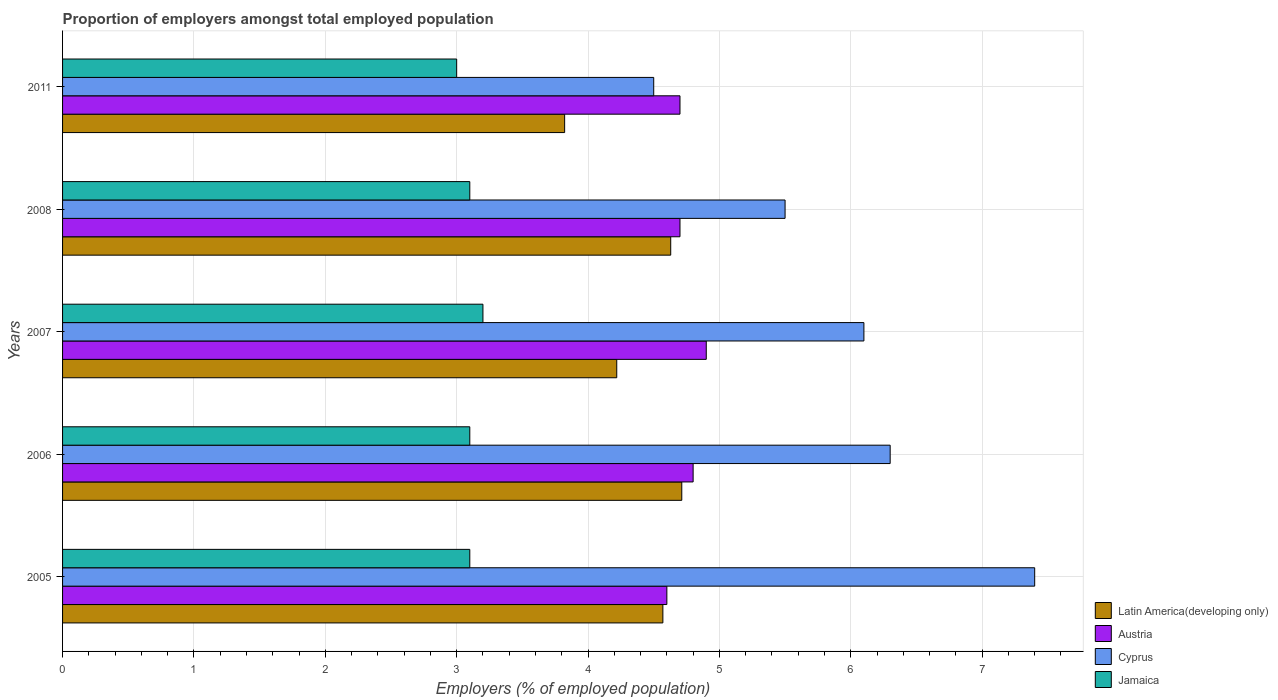How many different coloured bars are there?
Offer a terse response. 4. How many bars are there on the 1st tick from the top?
Your answer should be compact. 4. In how many cases, is the number of bars for a given year not equal to the number of legend labels?
Give a very brief answer. 0. What is the proportion of employers in Austria in 2008?
Offer a very short reply. 4.7. Across all years, what is the maximum proportion of employers in Latin America(developing only)?
Ensure brevity in your answer.  4.71. Across all years, what is the minimum proportion of employers in Cyprus?
Your answer should be very brief. 4.5. In which year was the proportion of employers in Latin America(developing only) maximum?
Your response must be concise. 2006. In which year was the proportion of employers in Jamaica minimum?
Your answer should be very brief. 2011. What is the total proportion of employers in Cyprus in the graph?
Make the answer very short. 29.8. What is the difference between the proportion of employers in Cyprus in 2005 and that in 2007?
Give a very brief answer. 1.3. What is the difference between the proportion of employers in Cyprus in 2005 and the proportion of employers in Jamaica in 2007?
Provide a succinct answer. 4.2. What is the average proportion of employers in Cyprus per year?
Offer a terse response. 5.96. In the year 2011, what is the difference between the proportion of employers in Latin America(developing only) and proportion of employers in Cyprus?
Your answer should be very brief. -0.68. What is the difference between the highest and the second highest proportion of employers in Latin America(developing only)?
Keep it short and to the point. 0.08. What is the difference between the highest and the lowest proportion of employers in Cyprus?
Provide a short and direct response. 2.9. In how many years, is the proportion of employers in Jamaica greater than the average proportion of employers in Jamaica taken over all years?
Provide a succinct answer. 1. Is the sum of the proportion of employers in Austria in 2005 and 2008 greater than the maximum proportion of employers in Latin America(developing only) across all years?
Provide a succinct answer. Yes. What does the 3rd bar from the top in 2008 represents?
Offer a very short reply. Austria. Is it the case that in every year, the sum of the proportion of employers in Jamaica and proportion of employers in Latin America(developing only) is greater than the proportion of employers in Cyprus?
Provide a succinct answer. Yes. Are all the bars in the graph horizontal?
Make the answer very short. Yes. Are the values on the major ticks of X-axis written in scientific E-notation?
Offer a terse response. No. Does the graph contain any zero values?
Offer a terse response. No. What is the title of the graph?
Your answer should be compact. Proportion of employers amongst total employed population. Does "West Bank and Gaza" appear as one of the legend labels in the graph?
Ensure brevity in your answer.  No. What is the label or title of the X-axis?
Your answer should be compact. Employers (% of employed population). What is the Employers (% of employed population) in Latin America(developing only) in 2005?
Your answer should be very brief. 4.57. What is the Employers (% of employed population) in Austria in 2005?
Give a very brief answer. 4.6. What is the Employers (% of employed population) of Cyprus in 2005?
Offer a very short reply. 7.4. What is the Employers (% of employed population) in Jamaica in 2005?
Make the answer very short. 3.1. What is the Employers (% of employed population) of Latin America(developing only) in 2006?
Offer a very short reply. 4.71. What is the Employers (% of employed population) of Austria in 2006?
Give a very brief answer. 4.8. What is the Employers (% of employed population) in Cyprus in 2006?
Make the answer very short. 6.3. What is the Employers (% of employed population) in Jamaica in 2006?
Offer a very short reply. 3.1. What is the Employers (% of employed population) of Latin America(developing only) in 2007?
Make the answer very short. 4.22. What is the Employers (% of employed population) in Austria in 2007?
Make the answer very short. 4.9. What is the Employers (% of employed population) in Cyprus in 2007?
Offer a very short reply. 6.1. What is the Employers (% of employed population) of Jamaica in 2007?
Give a very brief answer. 3.2. What is the Employers (% of employed population) of Latin America(developing only) in 2008?
Provide a succinct answer. 4.63. What is the Employers (% of employed population) in Austria in 2008?
Offer a very short reply. 4.7. What is the Employers (% of employed population) in Jamaica in 2008?
Keep it short and to the point. 3.1. What is the Employers (% of employed population) in Latin America(developing only) in 2011?
Keep it short and to the point. 3.82. What is the Employers (% of employed population) of Austria in 2011?
Provide a short and direct response. 4.7. What is the Employers (% of employed population) of Cyprus in 2011?
Keep it short and to the point. 4.5. Across all years, what is the maximum Employers (% of employed population) of Latin America(developing only)?
Make the answer very short. 4.71. Across all years, what is the maximum Employers (% of employed population) in Austria?
Offer a very short reply. 4.9. Across all years, what is the maximum Employers (% of employed population) of Cyprus?
Offer a terse response. 7.4. Across all years, what is the maximum Employers (% of employed population) of Jamaica?
Keep it short and to the point. 3.2. Across all years, what is the minimum Employers (% of employed population) in Latin America(developing only)?
Your answer should be compact. 3.82. Across all years, what is the minimum Employers (% of employed population) of Austria?
Offer a terse response. 4.6. What is the total Employers (% of employed population) in Latin America(developing only) in the graph?
Your answer should be very brief. 21.95. What is the total Employers (% of employed population) of Austria in the graph?
Your response must be concise. 23.7. What is the total Employers (% of employed population) of Cyprus in the graph?
Ensure brevity in your answer.  29.8. What is the total Employers (% of employed population) of Jamaica in the graph?
Offer a very short reply. 15.5. What is the difference between the Employers (% of employed population) of Latin America(developing only) in 2005 and that in 2006?
Your answer should be very brief. -0.14. What is the difference between the Employers (% of employed population) in Austria in 2005 and that in 2006?
Keep it short and to the point. -0.2. What is the difference between the Employers (% of employed population) of Latin America(developing only) in 2005 and that in 2007?
Your response must be concise. 0.35. What is the difference between the Employers (% of employed population) in Latin America(developing only) in 2005 and that in 2008?
Make the answer very short. -0.06. What is the difference between the Employers (% of employed population) in Cyprus in 2005 and that in 2008?
Keep it short and to the point. 1.9. What is the difference between the Employers (% of employed population) in Jamaica in 2005 and that in 2008?
Make the answer very short. 0. What is the difference between the Employers (% of employed population) of Latin America(developing only) in 2005 and that in 2011?
Give a very brief answer. 0.75. What is the difference between the Employers (% of employed population) of Cyprus in 2005 and that in 2011?
Give a very brief answer. 2.9. What is the difference between the Employers (% of employed population) in Jamaica in 2005 and that in 2011?
Ensure brevity in your answer.  0.1. What is the difference between the Employers (% of employed population) of Latin America(developing only) in 2006 and that in 2007?
Offer a terse response. 0.49. What is the difference between the Employers (% of employed population) of Austria in 2006 and that in 2007?
Give a very brief answer. -0.1. What is the difference between the Employers (% of employed population) of Cyprus in 2006 and that in 2007?
Provide a succinct answer. 0.2. What is the difference between the Employers (% of employed population) in Jamaica in 2006 and that in 2007?
Offer a terse response. -0.1. What is the difference between the Employers (% of employed population) in Latin America(developing only) in 2006 and that in 2008?
Keep it short and to the point. 0.08. What is the difference between the Employers (% of employed population) of Cyprus in 2006 and that in 2008?
Give a very brief answer. 0.8. What is the difference between the Employers (% of employed population) in Latin America(developing only) in 2006 and that in 2011?
Make the answer very short. 0.89. What is the difference between the Employers (% of employed population) of Austria in 2006 and that in 2011?
Make the answer very short. 0.1. What is the difference between the Employers (% of employed population) in Cyprus in 2006 and that in 2011?
Provide a succinct answer. 1.8. What is the difference between the Employers (% of employed population) in Latin America(developing only) in 2007 and that in 2008?
Your answer should be very brief. -0.41. What is the difference between the Employers (% of employed population) of Cyprus in 2007 and that in 2008?
Keep it short and to the point. 0.6. What is the difference between the Employers (% of employed population) of Latin America(developing only) in 2007 and that in 2011?
Your answer should be compact. 0.4. What is the difference between the Employers (% of employed population) in Austria in 2007 and that in 2011?
Give a very brief answer. 0.2. What is the difference between the Employers (% of employed population) of Latin America(developing only) in 2008 and that in 2011?
Ensure brevity in your answer.  0.81. What is the difference between the Employers (% of employed population) of Jamaica in 2008 and that in 2011?
Provide a short and direct response. 0.1. What is the difference between the Employers (% of employed population) in Latin America(developing only) in 2005 and the Employers (% of employed population) in Austria in 2006?
Your answer should be compact. -0.23. What is the difference between the Employers (% of employed population) in Latin America(developing only) in 2005 and the Employers (% of employed population) in Cyprus in 2006?
Keep it short and to the point. -1.73. What is the difference between the Employers (% of employed population) of Latin America(developing only) in 2005 and the Employers (% of employed population) of Jamaica in 2006?
Your answer should be compact. 1.47. What is the difference between the Employers (% of employed population) of Cyprus in 2005 and the Employers (% of employed population) of Jamaica in 2006?
Provide a short and direct response. 4.3. What is the difference between the Employers (% of employed population) in Latin America(developing only) in 2005 and the Employers (% of employed population) in Austria in 2007?
Give a very brief answer. -0.33. What is the difference between the Employers (% of employed population) of Latin America(developing only) in 2005 and the Employers (% of employed population) of Cyprus in 2007?
Provide a short and direct response. -1.53. What is the difference between the Employers (% of employed population) in Latin America(developing only) in 2005 and the Employers (% of employed population) in Jamaica in 2007?
Your answer should be very brief. 1.37. What is the difference between the Employers (% of employed population) of Austria in 2005 and the Employers (% of employed population) of Cyprus in 2007?
Give a very brief answer. -1.5. What is the difference between the Employers (% of employed population) of Cyprus in 2005 and the Employers (% of employed population) of Jamaica in 2007?
Provide a succinct answer. 4.2. What is the difference between the Employers (% of employed population) of Latin America(developing only) in 2005 and the Employers (% of employed population) of Austria in 2008?
Provide a short and direct response. -0.13. What is the difference between the Employers (% of employed population) in Latin America(developing only) in 2005 and the Employers (% of employed population) in Cyprus in 2008?
Your answer should be very brief. -0.93. What is the difference between the Employers (% of employed population) in Latin America(developing only) in 2005 and the Employers (% of employed population) in Jamaica in 2008?
Offer a very short reply. 1.47. What is the difference between the Employers (% of employed population) of Austria in 2005 and the Employers (% of employed population) of Jamaica in 2008?
Provide a short and direct response. 1.5. What is the difference between the Employers (% of employed population) of Cyprus in 2005 and the Employers (% of employed population) of Jamaica in 2008?
Offer a very short reply. 4.3. What is the difference between the Employers (% of employed population) in Latin America(developing only) in 2005 and the Employers (% of employed population) in Austria in 2011?
Give a very brief answer. -0.13. What is the difference between the Employers (% of employed population) in Latin America(developing only) in 2005 and the Employers (% of employed population) in Cyprus in 2011?
Give a very brief answer. 0.07. What is the difference between the Employers (% of employed population) in Latin America(developing only) in 2005 and the Employers (% of employed population) in Jamaica in 2011?
Offer a terse response. 1.57. What is the difference between the Employers (% of employed population) of Austria in 2005 and the Employers (% of employed population) of Jamaica in 2011?
Your answer should be compact. 1.6. What is the difference between the Employers (% of employed population) in Latin America(developing only) in 2006 and the Employers (% of employed population) in Austria in 2007?
Your response must be concise. -0.19. What is the difference between the Employers (% of employed population) in Latin America(developing only) in 2006 and the Employers (% of employed population) in Cyprus in 2007?
Your answer should be compact. -1.39. What is the difference between the Employers (% of employed population) in Latin America(developing only) in 2006 and the Employers (% of employed population) in Jamaica in 2007?
Your answer should be very brief. 1.51. What is the difference between the Employers (% of employed population) in Austria in 2006 and the Employers (% of employed population) in Cyprus in 2007?
Your response must be concise. -1.3. What is the difference between the Employers (% of employed population) in Austria in 2006 and the Employers (% of employed population) in Jamaica in 2007?
Give a very brief answer. 1.6. What is the difference between the Employers (% of employed population) of Cyprus in 2006 and the Employers (% of employed population) of Jamaica in 2007?
Offer a very short reply. 3.1. What is the difference between the Employers (% of employed population) in Latin America(developing only) in 2006 and the Employers (% of employed population) in Austria in 2008?
Ensure brevity in your answer.  0.01. What is the difference between the Employers (% of employed population) in Latin America(developing only) in 2006 and the Employers (% of employed population) in Cyprus in 2008?
Your answer should be very brief. -0.79. What is the difference between the Employers (% of employed population) in Latin America(developing only) in 2006 and the Employers (% of employed population) in Jamaica in 2008?
Provide a succinct answer. 1.61. What is the difference between the Employers (% of employed population) in Cyprus in 2006 and the Employers (% of employed population) in Jamaica in 2008?
Make the answer very short. 3.2. What is the difference between the Employers (% of employed population) in Latin America(developing only) in 2006 and the Employers (% of employed population) in Austria in 2011?
Provide a short and direct response. 0.01. What is the difference between the Employers (% of employed population) of Latin America(developing only) in 2006 and the Employers (% of employed population) of Cyprus in 2011?
Make the answer very short. 0.21. What is the difference between the Employers (% of employed population) of Latin America(developing only) in 2006 and the Employers (% of employed population) of Jamaica in 2011?
Your response must be concise. 1.71. What is the difference between the Employers (% of employed population) in Cyprus in 2006 and the Employers (% of employed population) in Jamaica in 2011?
Offer a very short reply. 3.3. What is the difference between the Employers (% of employed population) of Latin America(developing only) in 2007 and the Employers (% of employed population) of Austria in 2008?
Keep it short and to the point. -0.48. What is the difference between the Employers (% of employed population) of Latin America(developing only) in 2007 and the Employers (% of employed population) of Cyprus in 2008?
Your answer should be very brief. -1.28. What is the difference between the Employers (% of employed population) of Latin America(developing only) in 2007 and the Employers (% of employed population) of Jamaica in 2008?
Offer a very short reply. 1.12. What is the difference between the Employers (% of employed population) in Austria in 2007 and the Employers (% of employed population) in Cyprus in 2008?
Offer a very short reply. -0.6. What is the difference between the Employers (% of employed population) of Latin America(developing only) in 2007 and the Employers (% of employed population) of Austria in 2011?
Provide a short and direct response. -0.48. What is the difference between the Employers (% of employed population) in Latin America(developing only) in 2007 and the Employers (% of employed population) in Cyprus in 2011?
Offer a terse response. -0.28. What is the difference between the Employers (% of employed population) in Latin America(developing only) in 2007 and the Employers (% of employed population) in Jamaica in 2011?
Your answer should be very brief. 1.22. What is the difference between the Employers (% of employed population) of Austria in 2007 and the Employers (% of employed population) of Cyprus in 2011?
Offer a very short reply. 0.4. What is the difference between the Employers (% of employed population) of Austria in 2007 and the Employers (% of employed population) of Jamaica in 2011?
Keep it short and to the point. 1.9. What is the difference between the Employers (% of employed population) in Latin America(developing only) in 2008 and the Employers (% of employed population) in Austria in 2011?
Offer a very short reply. -0.07. What is the difference between the Employers (% of employed population) of Latin America(developing only) in 2008 and the Employers (% of employed population) of Cyprus in 2011?
Offer a very short reply. 0.13. What is the difference between the Employers (% of employed population) in Latin America(developing only) in 2008 and the Employers (% of employed population) in Jamaica in 2011?
Keep it short and to the point. 1.63. What is the difference between the Employers (% of employed population) of Austria in 2008 and the Employers (% of employed population) of Cyprus in 2011?
Offer a very short reply. 0.2. What is the difference between the Employers (% of employed population) of Austria in 2008 and the Employers (% of employed population) of Jamaica in 2011?
Offer a terse response. 1.7. What is the difference between the Employers (% of employed population) in Cyprus in 2008 and the Employers (% of employed population) in Jamaica in 2011?
Offer a very short reply. 2.5. What is the average Employers (% of employed population) of Latin America(developing only) per year?
Provide a short and direct response. 4.39. What is the average Employers (% of employed population) of Austria per year?
Provide a short and direct response. 4.74. What is the average Employers (% of employed population) in Cyprus per year?
Your answer should be compact. 5.96. What is the average Employers (% of employed population) of Jamaica per year?
Make the answer very short. 3.1. In the year 2005, what is the difference between the Employers (% of employed population) in Latin America(developing only) and Employers (% of employed population) in Austria?
Offer a terse response. -0.03. In the year 2005, what is the difference between the Employers (% of employed population) of Latin America(developing only) and Employers (% of employed population) of Cyprus?
Make the answer very short. -2.83. In the year 2005, what is the difference between the Employers (% of employed population) in Latin America(developing only) and Employers (% of employed population) in Jamaica?
Provide a short and direct response. 1.47. In the year 2005, what is the difference between the Employers (% of employed population) of Austria and Employers (% of employed population) of Cyprus?
Your answer should be very brief. -2.8. In the year 2005, what is the difference between the Employers (% of employed population) in Austria and Employers (% of employed population) in Jamaica?
Offer a terse response. 1.5. In the year 2006, what is the difference between the Employers (% of employed population) of Latin America(developing only) and Employers (% of employed population) of Austria?
Your response must be concise. -0.09. In the year 2006, what is the difference between the Employers (% of employed population) of Latin America(developing only) and Employers (% of employed population) of Cyprus?
Keep it short and to the point. -1.59. In the year 2006, what is the difference between the Employers (% of employed population) of Latin America(developing only) and Employers (% of employed population) of Jamaica?
Your answer should be compact. 1.61. In the year 2006, what is the difference between the Employers (% of employed population) of Austria and Employers (% of employed population) of Cyprus?
Your answer should be compact. -1.5. In the year 2006, what is the difference between the Employers (% of employed population) in Austria and Employers (% of employed population) in Jamaica?
Keep it short and to the point. 1.7. In the year 2006, what is the difference between the Employers (% of employed population) of Cyprus and Employers (% of employed population) of Jamaica?
Offer a very short reply. 3.2. In the year 2007, what is the difference between the Employers (% of employed population) of Latin America(developing only) and Employers (% of employed population) of Austria?
Provide a succinct answer. -0.68. In the year 2007, what is the difference between the Employers (% of employed population) in Latin America(developing only) and Employers (% of employed population) in Cyprus?
Offer a terse response. -1.88. In the year 2007, what is the difference between the Employers (% of employed population) of Latin America(developing only) and Employers (% of employed population) of Jamaica?
Your answer should be very brief. 1.02. In the year 2007, what is the difference between the Employers (% of employed population) in Austria and Employers (% of employed population) in Cyprus?
Offer a very short reply. -1.2. In the year 2007, what is the difference between the Employers (% of employed population) of Austria and Employers (% of employed population) of Jamaica?
Give a very brief answer. 1.7. In the year 2007, what is the difference between the Employers (% of employed population) of Cyprus and Employers (% of employed population) of Jamaica?
Offer a terse response. 2.9. In the year 2008, what is the difference between the Employers (% of employed population) in Latin America(developing only) and Employers (% of employed population) in Austria?
Keep it short and to the point. -0.07. In the year 2008, what is the difference between the Employers (% of employed population) in Latin America(developing only) and Employers (% of employed population) in Cyprus?
Your answer should be very brief. -0.87. In the year 2008, what is the difference between the Employers (% of employed population) in Latin America(developing only) and Employers (% of employed population) in Jamaica?
Offer a terse response. 1.53. In the year 2008, what is the difference between the Employers (% of employed population) in Austria and Employers (% of employed population) in Jamaica?
Your response must be concise. 1.6. In the year 2008, what is the difference between the Employers (% of employed population) in Cyprus and Employers (% of employed population) in Jamaica?
Give a very brief answer. 2.4. In the year 2011, what is the difference between the Employers (% of employed population) in Latin America(developing only) and Employers (% of employed population) in Austria?
Your answer should be very brief. -0.88. In the year 2011, what is the difference between the Employers (% of employed population) of Latin America(developing only) and Employers (% of employed population) of Cyprus?
Provide a succinct answer. -0.68. In the year 2011, what is the difference between the Employers (% of employed population) in Latin America(developing only) and Employers (% of employed population) in Jamaica?
Your answer should be very brief. 0.82. In the year 2011, what is the difference between the Employers (% of employed population) in Austria and Employers (% of employed population) in Jamaica?
Your answer should be very brief. 1.7. In the year 2011, what is the difference between the Employers (% of employed population) of Cyprus and Employers (% of employed population) of Jamaica?
Ensure brevity in your answer.  1.5. What is the ratio of the Employers (% of employed population) of Latin America(developing only) in 2005 to that in 2006?
Your response must be concise. 0.97. What is the ratio of the Employers (% of employed population) of Austria in 2005 to that in 2006?
Ensure brevity in your answer.  0.96. What is the ratio of the Employers (% of employed population) of Cyprus in 2005 to that in 2006?
Ensure brevity in your answer.  1.17. What is the ratio of the Employers (% of employed population) of Latin America(developing only) in 2005 to that in 2007?
Provide a succinct answer. 1.08. What is the ratio of the Employers (% of employed population) in Austria in 2005 to that in 2007?
Ensure brevity in your answer.  0.94. What is the ratio of the Employers (% of employed population) of Cyprus in 2005 to that in 2007?
Your answer should be compact. 1.21. What is the ratio of the Employers (% of employed population) in Jamaica in 2005 to that in 2007?
Provide a succinct answer. 0.97. What is the ratio of the Employers (% of employed population) in Latin America(developing only) in 2005 to that in 2008?
Your answer should be very brief. 0.99. What is the ratio of the Employers (% of employed population) in Austria in 2005 to that in 2008?
Ensure brevity in your answer.  0.98. What is the ratio of the Employers (% of employed population) in Cyprus in 2005 to that in 2008?
Offer a very short reply. 1.35. What is the ratio of the Employers (% of employed population) in Latin America(developing only) in 2005 to that in 2011?
Offer a terse response. 1.2. What is the ratio of the Employers (% of employed population) in Austria in 2005 to that in 2011?
Keep it short and to the point. 0.98. What is the ratio of the Employers (% of employed population) in Cyprus in 2005 to that in 2011?
Your response must be concise. 1.64. What is the ratio of the Employers (% of employed population) in Jamaica in 2005 to that in 2011?
Your response must be concise. 1.03. What is the ratio of the Employers (% of employed population) of Latin America(developing only) in 2006 to that in 2007?
Make the answer very short. 1.12. What is the ratio of the Employers (% of employed population) of Austria in 2006 to that in 2007?
Offer a terse response. 0.98. What is the ratio of the Employers (% of employed population) in Cyprus in 2006 to that in 2007?
Ensure brevity in your answer.  1.03. What is the ratio of the Employers (% of employed population) of Jamaica in 2006 to that in 2007?
Your answer should be compact. 0.97. What is the ratio of the Employers (% of employed population) of Latin America(developing only) in 2006 to that in 2008?
Give a very brief answer. 1.02. What is the ratio of the Employers (% of employed population) in Austria in 2006 to that in 2008?
Make the answer very short. 1.02. What is the ratio of the Employers (% of employed population) in Cyprus in 2006 to that in 2008?
Your answer should be very brief. 1.15. What is the ratio of the Employers (% of employed population) in Jamaica in 2006 to that in 2008?
Ensure brevity in your answer.  1. What is the ratio of the Employers (% of employed population) of Latin America(developing only) in 2006 to that in 2011?
Ensure brevity in your answer.  1.23. What is the ratio of the Employers (% of employed population) in Austria in 2006 to that in 2011?
Provide a succinct answer. 1.02. What is the ratio of the Employers (% of employed population) of Jamaica in 2006 to that in 2011?
Make the answer very short. 1.03. What is the ratio of the Employers (% of employed population) in Latin America(developing only) in 2007 to that in 2008?
Offer a very short reply. 0.91. What is the ratio of the Employers (% of employed population) in Austria in 2007 to that in 2008?
Your answer should be very brief. 1.04. What is the ratio of the Employers (% of employed population) of Cyprus in 2007 to that in 2008?
Keep it short and to the point. 1.11. What is the ratio of the Employers (% of employed population) of Jamaica in 2007 to that in 2008?
Your answer should be compact. 1.03. What is the ratio of the Employers (% of employed population) in Latin America(developing only) in 2007 to that in 2011?
Give a very brief answer. 1.1. What is the ratio of the Employers (% of employed population) of Austria in 2007 to that in 2011?
Keep it short and to the point. 1.04. What is the ratio of the Employers (% of employed population) of Cyprus in 2007 to that in 2011?
Your answer should be compact. 1.36. What is the ratio of the Employers (% of employed population) of Jamaica in 2007 to that in 2011?
Keep it short and to the point. 1.07. What is the ratio of the Employers (% of employed population) in Latin America(developing only) in 2008 to that in 2011?
Provide a short and direct response. 1.21. What is the ratio of the Employers (% of employed population) in Austria in 2008 to that in 2011?
Your answer should be compact. 1. What is the ratio of the Employers (% of employed population) in Cyprus in 2008 to that in 2011?
Keep it short and to the point. 1.22. What is the ratio of the Employers (% of employed population) in Jamaica in 2008 to that in 2011?
Offer a very short reply. 1.03. What is the difference between the highest and the second highest Employers (% of employed population) in Latin America(developing only)?
Your answer should be compact. 0.08. What is the difference between the highest and the second highest Employers (% of employed population) in Jamaica?
Offer a terse response. 0.1. What is the difference between the highest and the lowest Employers (% of employed population) in Latin America(developing only)?
Provide a short and direct response. 0.89. What is the difference between the highest and the lowest Employers (% of employed population) in Austria?
Provide a succinct answer. 0.3. What is the difference between the highest and the lowest Employers (% of employed population) in Cyprus?
Make the answer very short. 2.9. What is the difference between the highest and the lowest Employers (% of employed population) in Jamaica?
Ensure brevity in your answer.  0.2. 